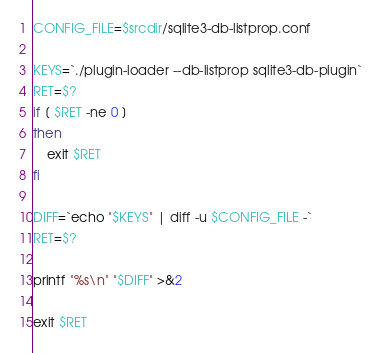<code> <loc_0><loc_0><loc_500><loc_500><_Bash_>
CONFIG_FILE=$srcdir/sqlite3-db-listprop.conf

KEYS=`./plugin-loader --db-listprop sqlite3-db-plugin`
RET=$?
if [ $RET -ne 0 ]
then
    exit $RET
fi

DIFF=`echo "$KEYS" | diff -u $CONFIG_FILE -`
RET=$?

printf "%s\n" "$DIFF" >&2

exit $RET
</code> 